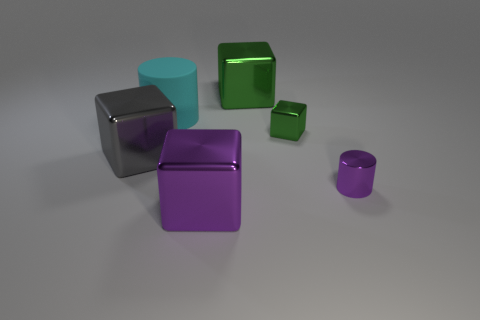Subtract all large gray shiny cubes. How many cubes are left? 3 Subtract all green blocks. How many blocks are left? 2 Subtract 3 cubes. How many cubes are left? 1 Add 3 large brown matte objects. How many objects exist? 9 Subtract all blocks. How many objects are left? 2 Add 2 gray metallic blocks. How many gray metallic blocks exist? 3 Subtract 0 red cylinders. How many objects are left? 6 Subtract all green cylinders. Subtract all blue balls. How many cylinders are left? 2 Subtract all red balls. How many red blocks are left? 0 Subtract all rubber spheres. Subtract all large things. How many objects are left? 2 